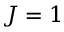<formula> <loc_0><loc_0><loc_500><loc_500>J = 1</formula> 